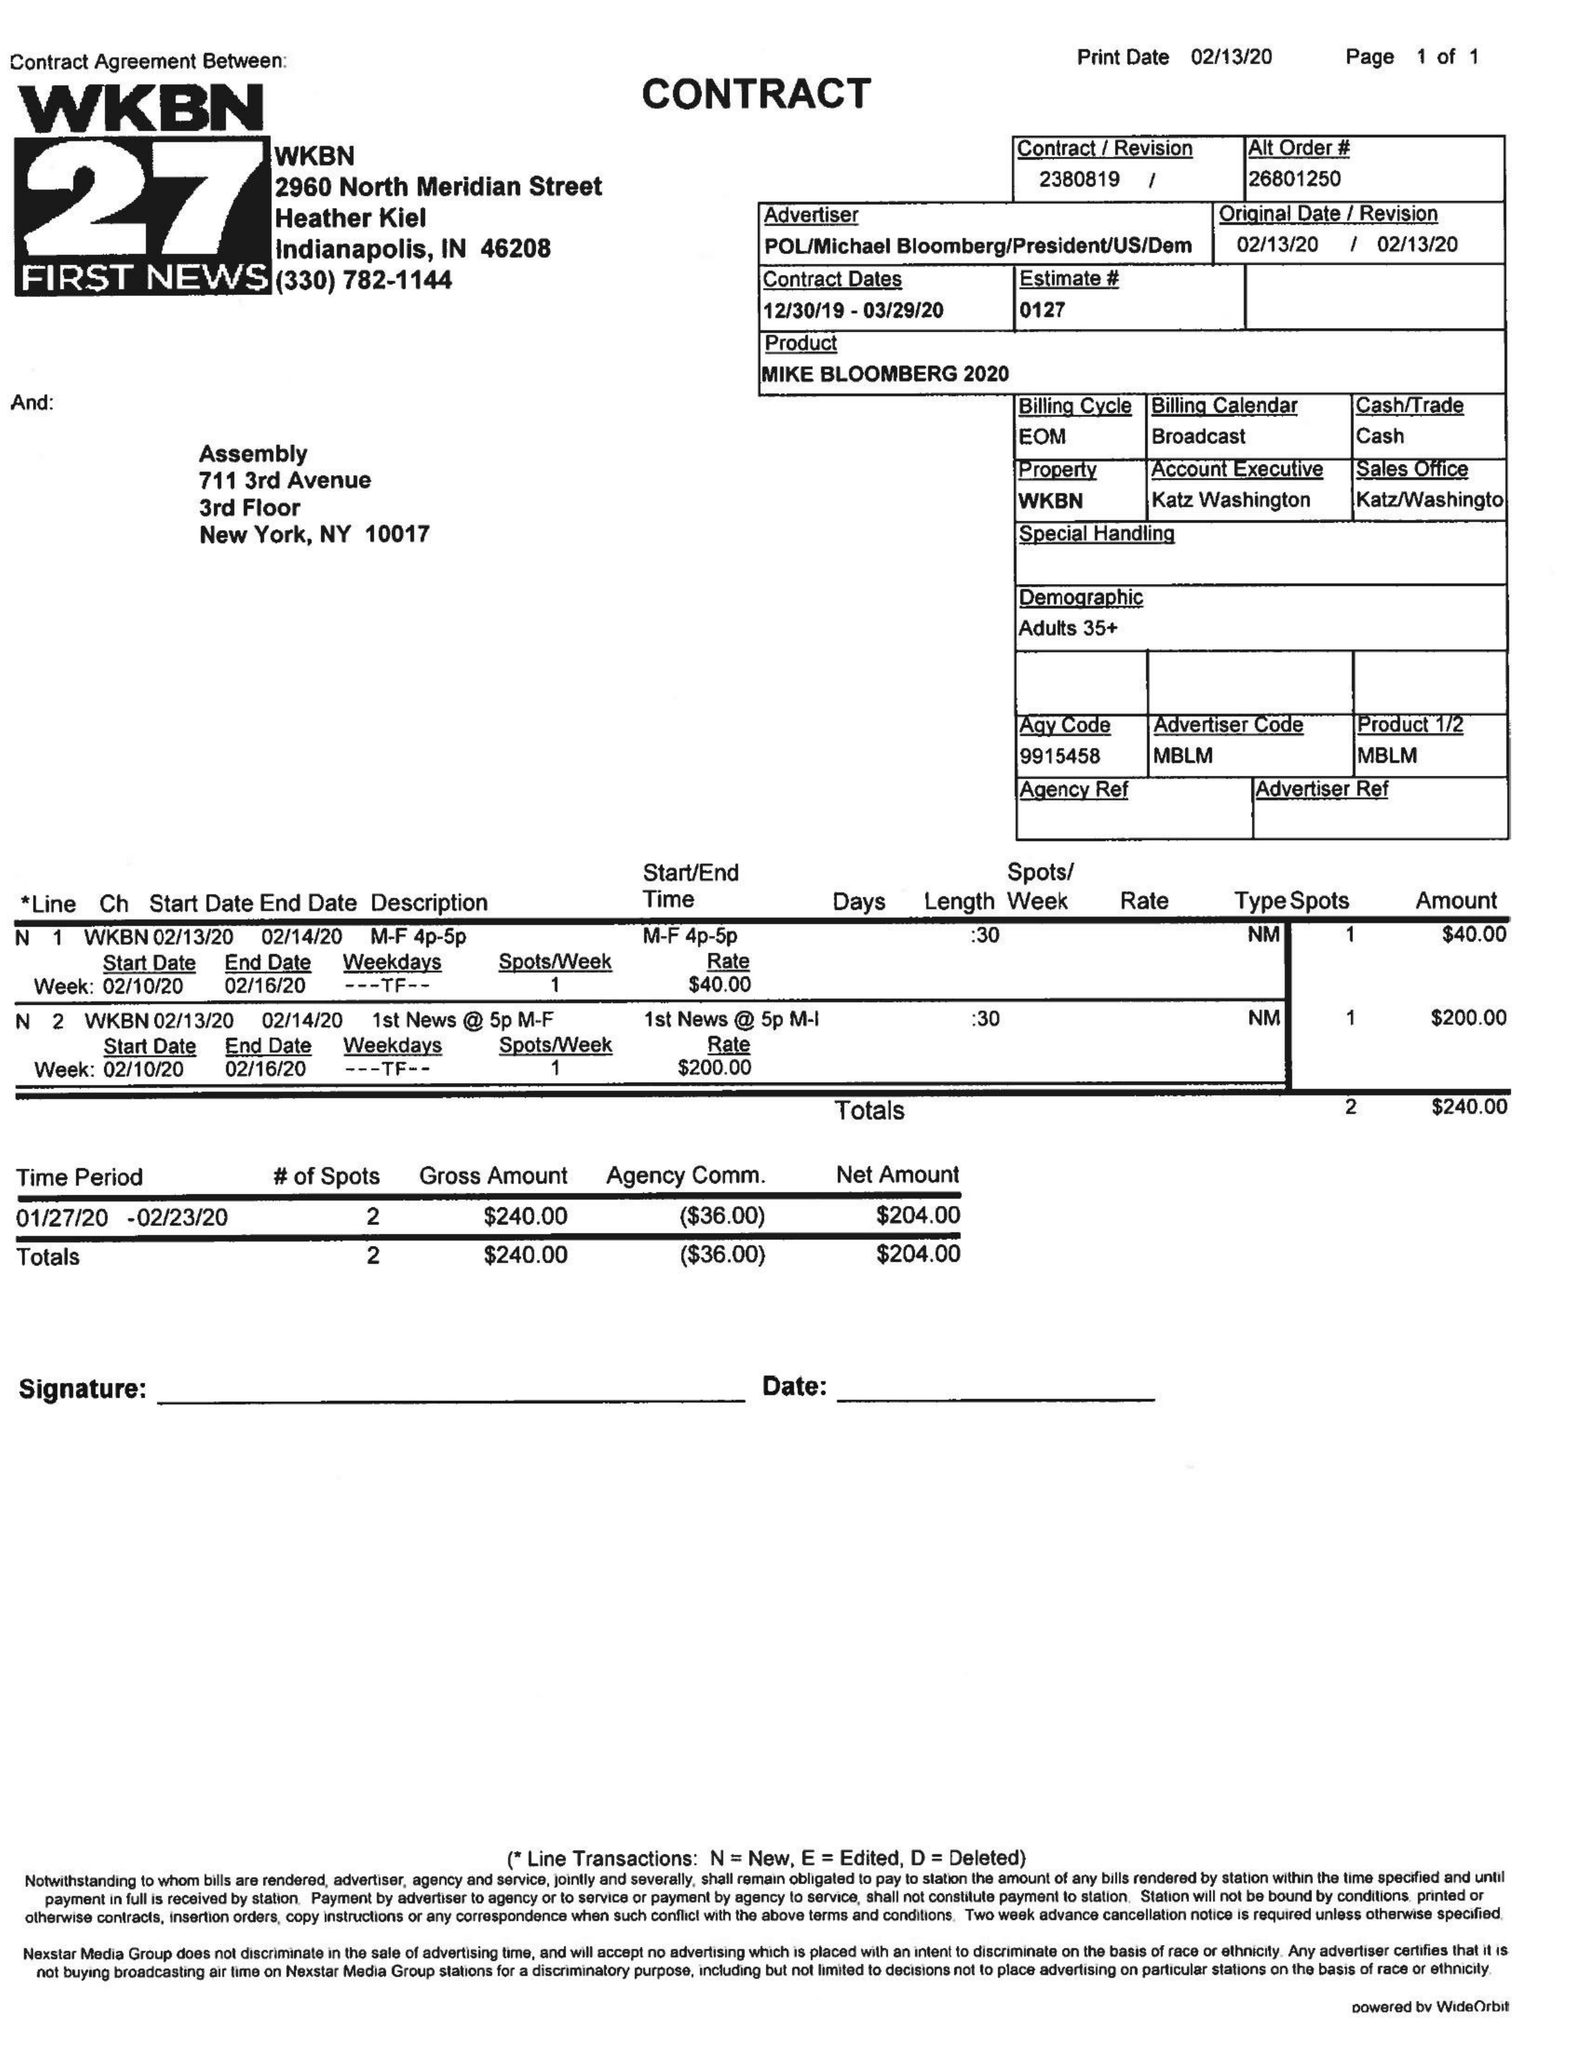What is the value for the contract_num?
Answer the question using a single word or phrase. 2380819 